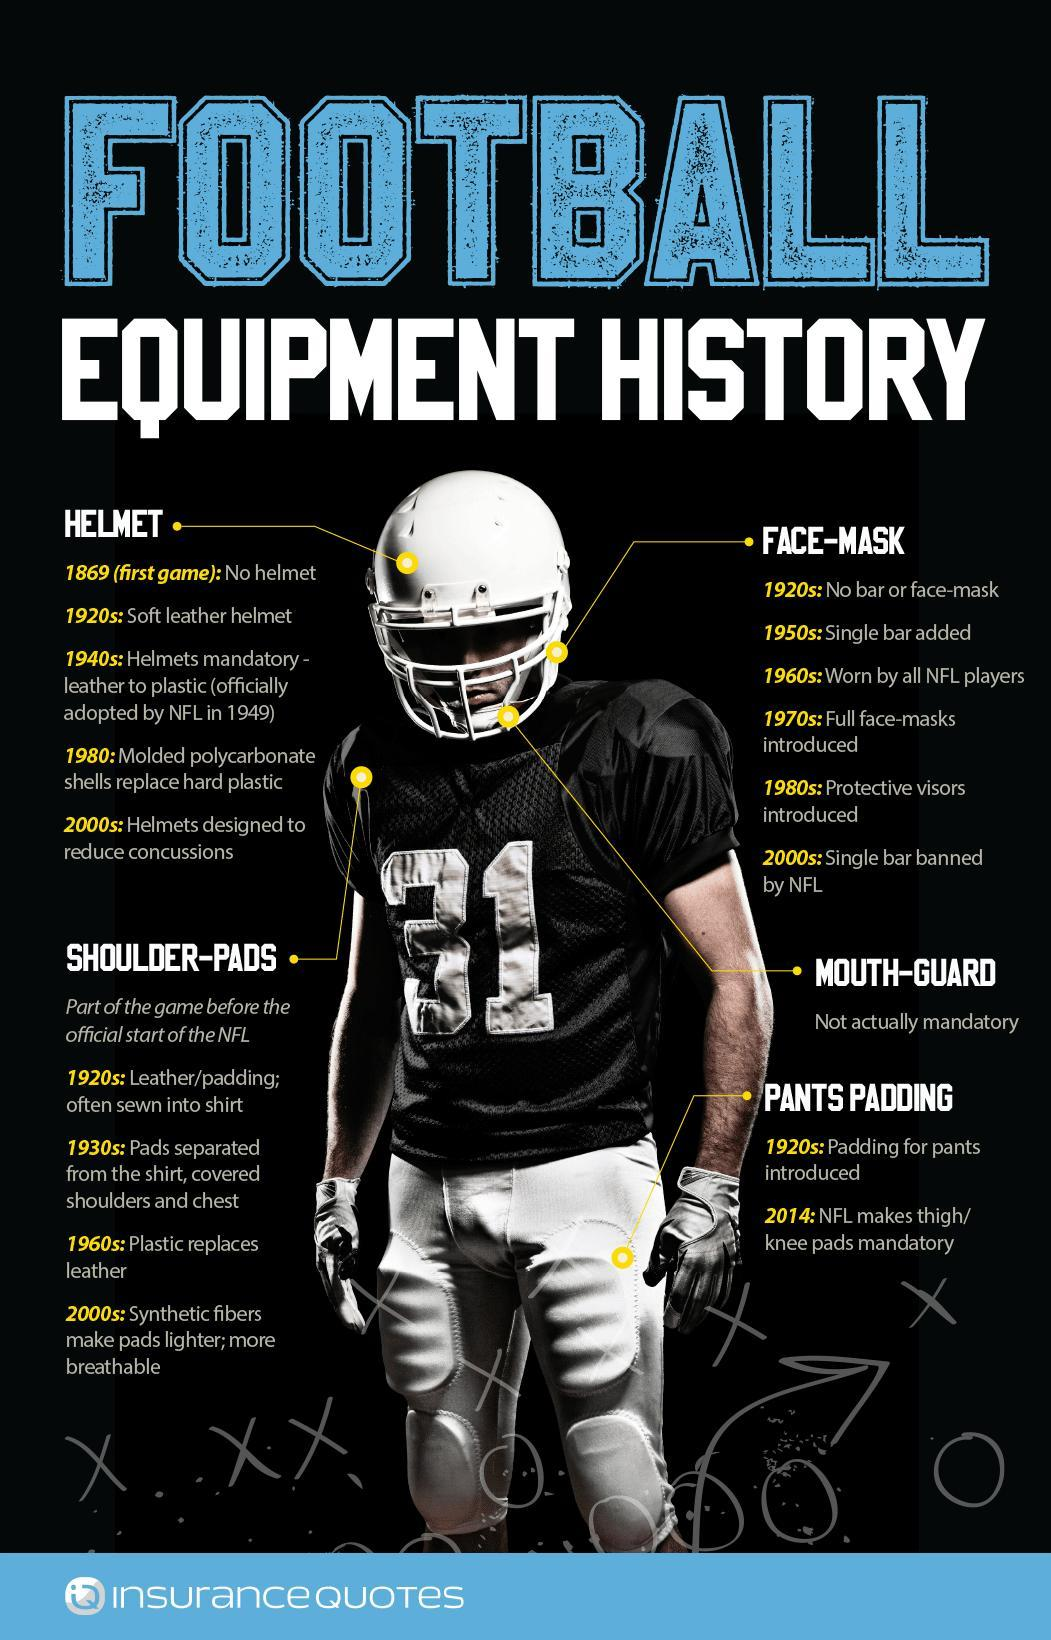When was the padding on pants compulsory, 1920, 1960, 2000, or 2014?
Answer the question with a short phrase. 2014 When was the light weighted pads introduced for the shoulders, 1920s, 1930s,1960s, or 2000s? 1960s Which football equipment is not compulsory while playing football? MOUTH-GUARD When were specialized head gears for lowering injuries designed, 1980s, 2000s, or 1970s? 2000s What jersey number of the player? 31 When was a face mask with one bar introduced, 1920s, 1940s, 1950s, or 1960s? 1950s 